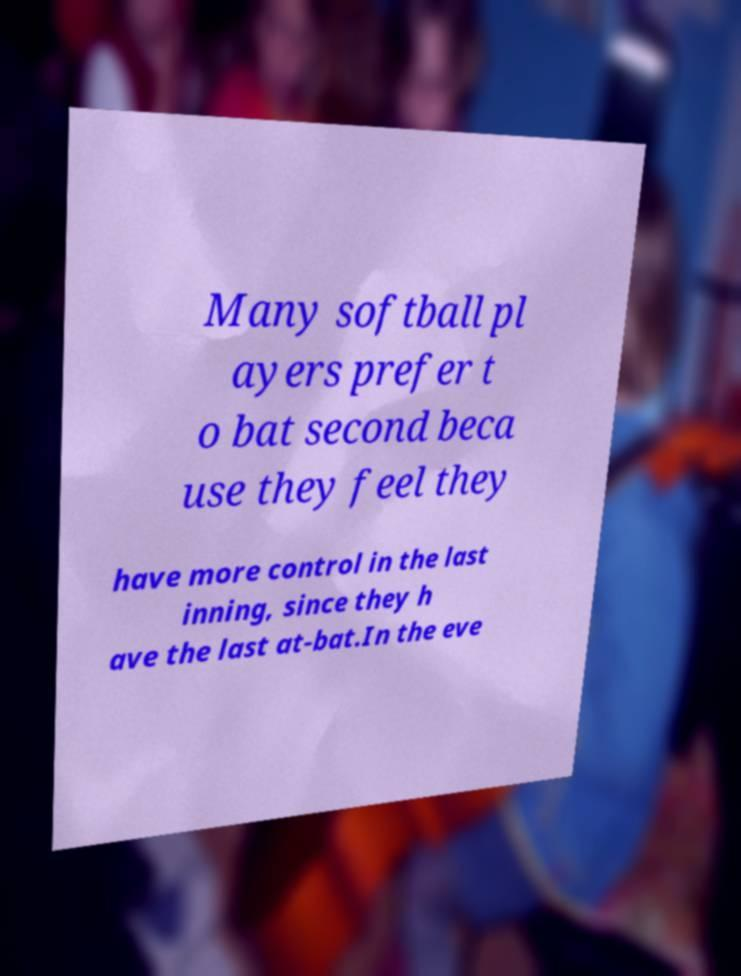Could you extract and type out the text from this image? Many softball pl ayers prefer t o bat second beca use they feel they have more control in the last inning, since they h ave the last at-bat.In the eve 